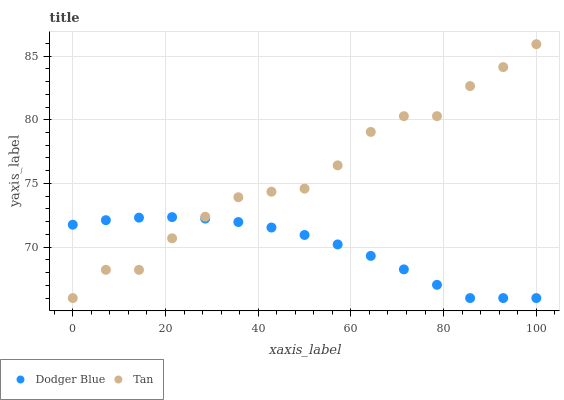Does Dodger Blue have the minimum area under the curve?
Answer yes or no. Yes. Does Tan have the maximum area under the curve?
Answer yes or no. Yes. Does Dodger Blue have the maximum area under the curve?
Answer yes or no. No. Is Dodger Blue the smoothest?
Answer yes or no. Yes. Is Tan the roughest?
Answer yes or no. Yes. Is Dodger Blue the roughest?
Answer yes or no. No. Does Tan have the lowest value?
Answer yes or no. Yes. Does Tan have the highest value?
Answer yes or no. Yes. Does Dodger Blue have the highest value?
Answer yes or no. No. Does Dodger Blue intersect Tan?
Answer yes or no. Yes. Is Dodger Blue less than Tan?
Answer yes or no. No. Is Dodger Blue greater than Tan?
Answer yes or no. No. 